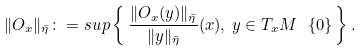<formula> <loc_0><loc_0><loc_500><loc_500>\| O _ { x } \| _ { \bar { \eta } } \colon = s u p \left \{ \, \frac { \| O _ { x } ( y ) \| _ { \bar { \eta } } } { \| y \| _ { \bar { \eta } } } ( x ) , \, y \in { T } _ { x } { M } \ \{ 0 \} \, \right \} .</formula> 